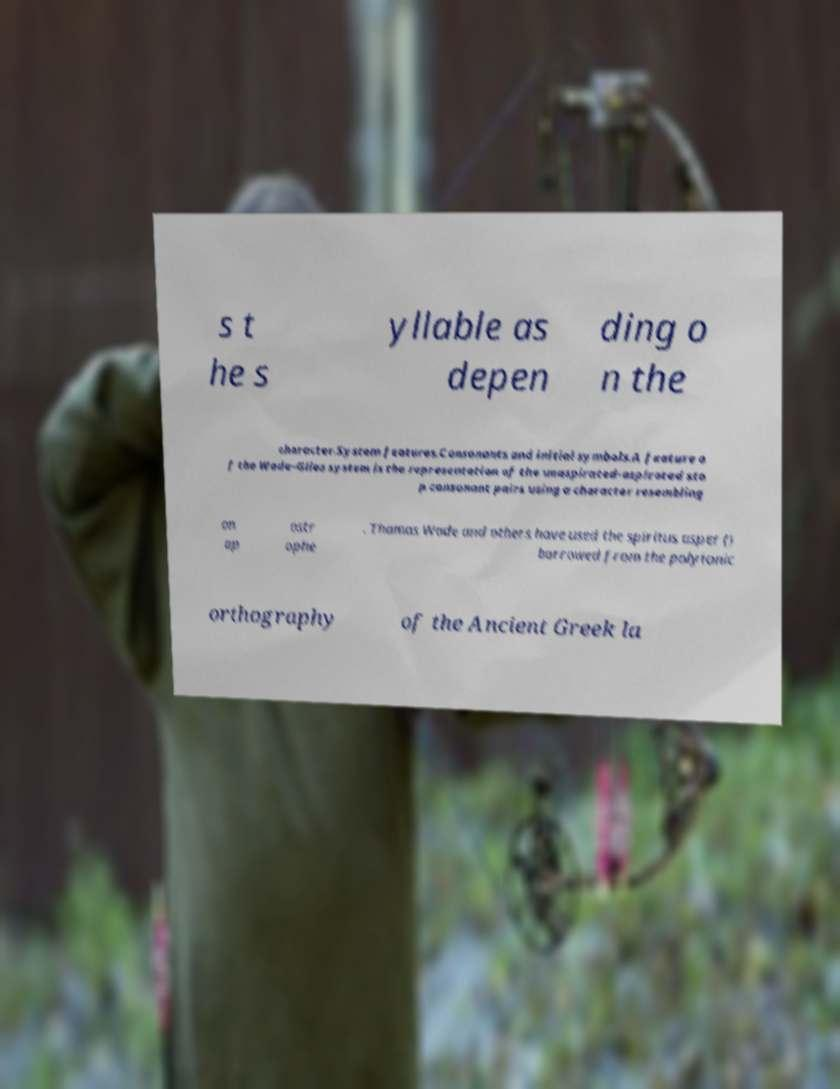For documentation purposes, I need the text within this image transcribed. Could you provide that? s t he s yllable as depen ding o n the character.System features.Consonants and initial symbols.A feature o f the Wade–Giles system is the representation of the unaspirated-aspirated sto p consonant pairs using a character resembling an ap ostr ophe . Thomas Wade and others have used the spiritus asper () borrowed from the polytonic orthography of the Ancient Greek la 